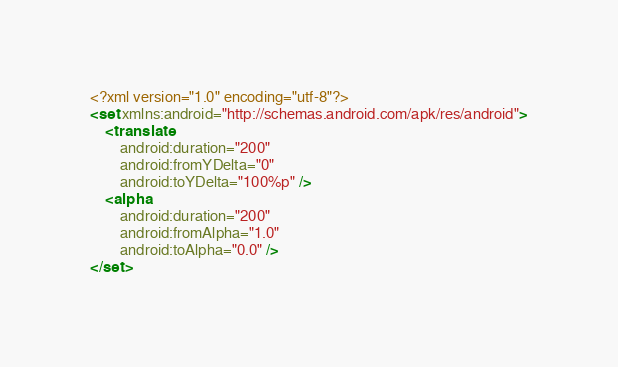Convert code to text. <code><loc_0><loc_0><loc_500><loc_500><_XML_><?xml version="1.0" encoding="utf-8"?>
<set xmlns:android="http://schemas.android.com/apk/res/android">
    <translate
        android:duration="200"
        android:fromYDelta="0"
        android:toYDelta="100%p" />
    <alpha
        android:duration="200"
        android:fromAlpha="1.0"
        android:toAlpha="0.0" />
</set></code> 